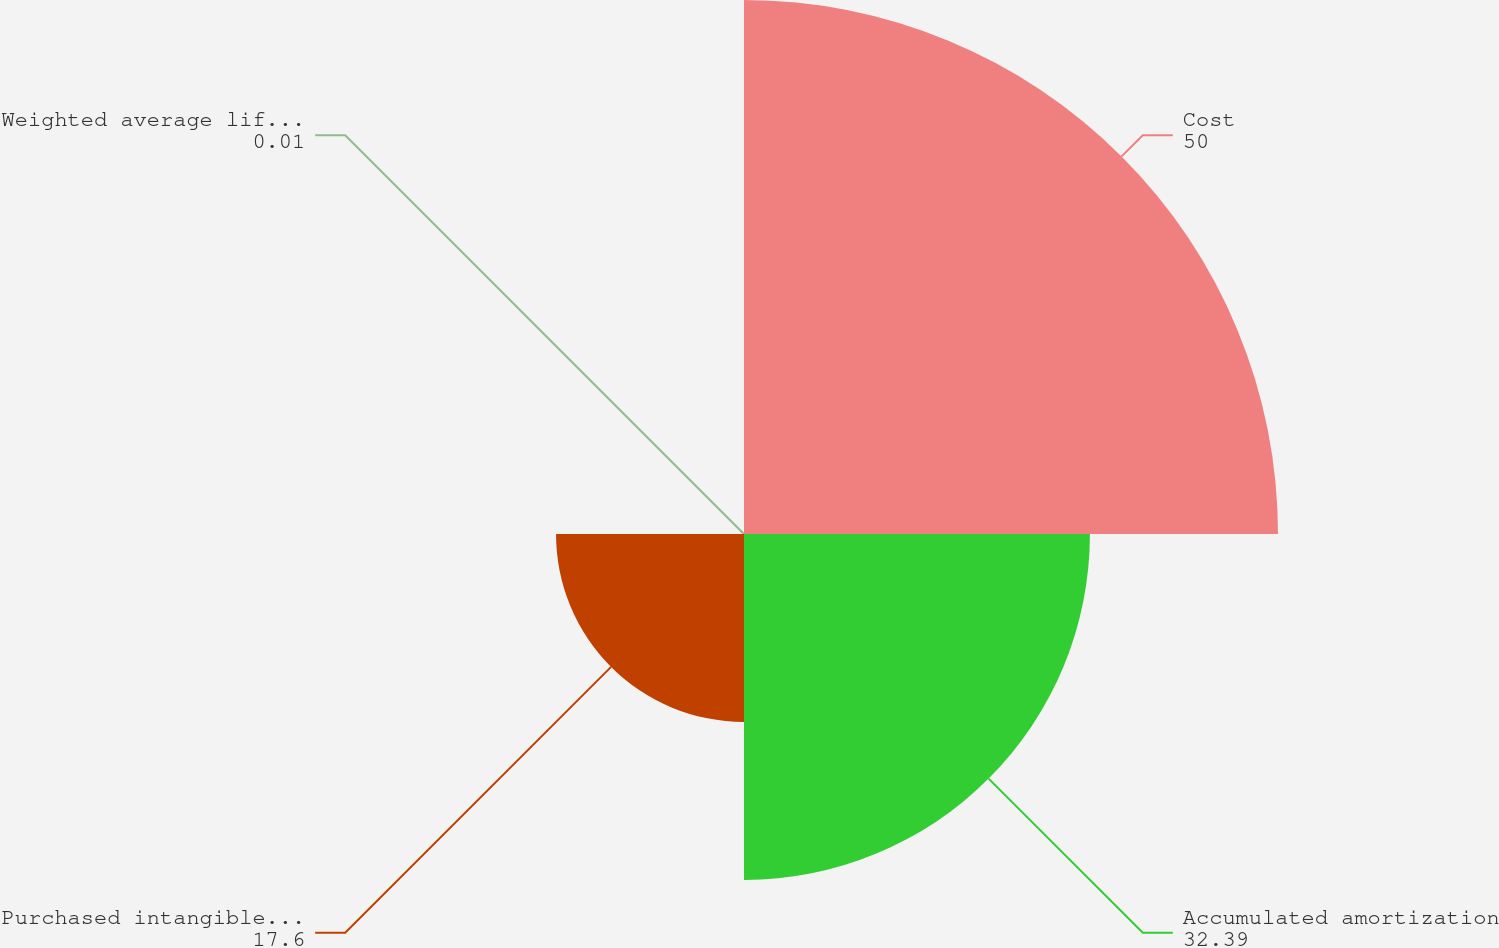<chart> <loc_0><loc_0><loc_500><loc_500><pie_chart><fcel>Cost<fcel>Accumulated amortization<fcel>Purchased intangible assets<fcel>Weighted average life in years<nl><fcel>50.0%<fcel>32.39%<fcel>17.6%<fcel>0.01%<nl></chart> 